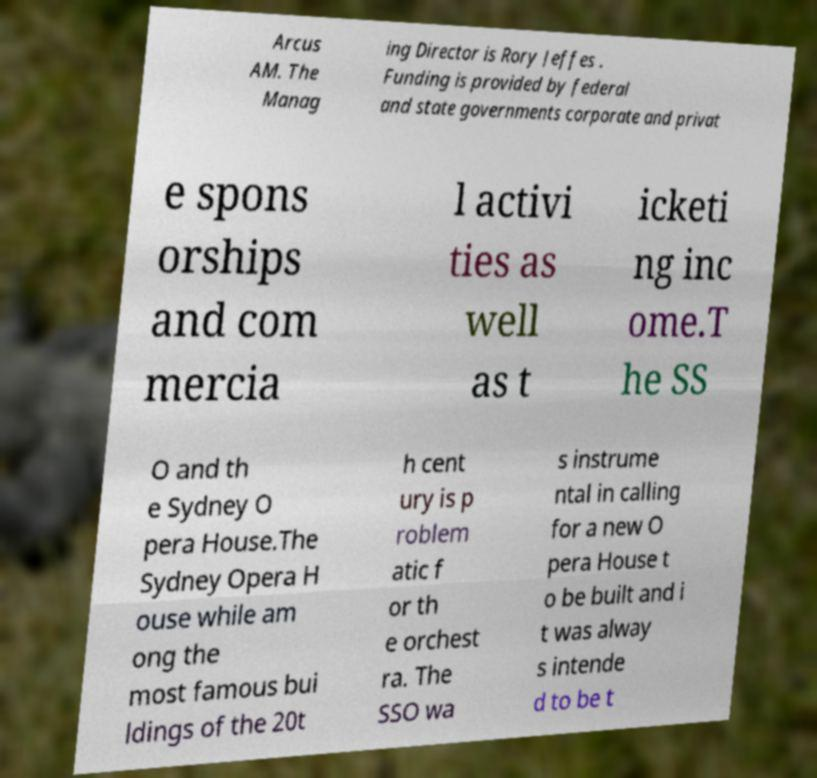Can you accurately transcribe the text from the provided image for me? Arcus AM. The Manag ing Director is Rory Jeffes . Funding is provided by federal and state governments corporate and privat e spons orships and com mercia l activi ties as well as t icketi ng inc ome.T he SS O and th e Sydney O pera House.The Sydney Opera H ouse while am ong the most famous bui ldings of the 20t h cent ury is p roblem atic f or th e orchest ra. The SSO wa s instrume ntal in calling for a new O pera House t o be built and i t was alway s intende d to be t 